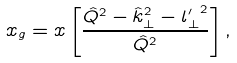Convert formula to latex. <formula><loc_0><loc_0><loc_500><loc_500>x _ { g } = x \left [ \frac { \hat { Q } ^ { 2 } - \hat { k } _ { \perp } ^ { 2 } - { l ^ { \prime } _ { \perp } } ^ { 2 } } { \hat { Q } ^ { 2 } } \right ] ,</formula> 